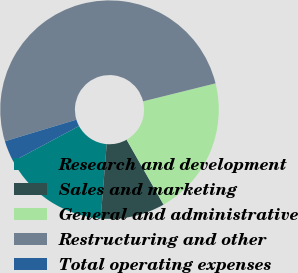Convert chart. <chart><loc_0><loc_0><loc_500><loc_500><pie_chart><fcel>Research and development<fcel>Sales and marketing<fcel>General and administrative<fcel>Restructuring and other<fcel>Total operating expenses<nl><fcel>15.87%<fcel>9.52%<fcel>20.63%<fcel>50.79%<fcel>3.17%<nl></chart> 